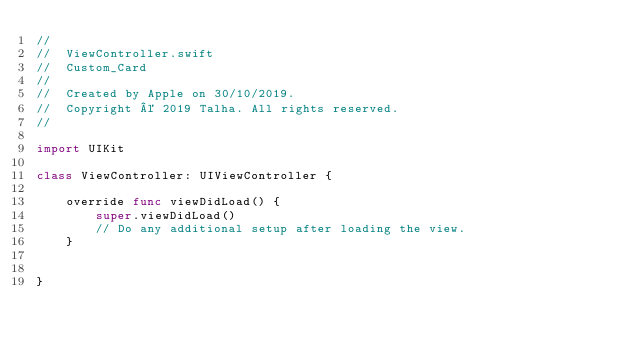<code> <loc_0><loc_0><loc_500><loc_500><_Swift_>//
//  ViewController.swift
//  Custom_Card
//
//  Created by Apple on 30/10/2019.
//  Copyright © 2019 Talha. All rights reserved.
//

import UIKit

class ViewController: UIViewController {

    override func viewDidLoad() {
        super.viewDidLoad()
        // Do any additional setup after loading the view.
    }


}

</code> 